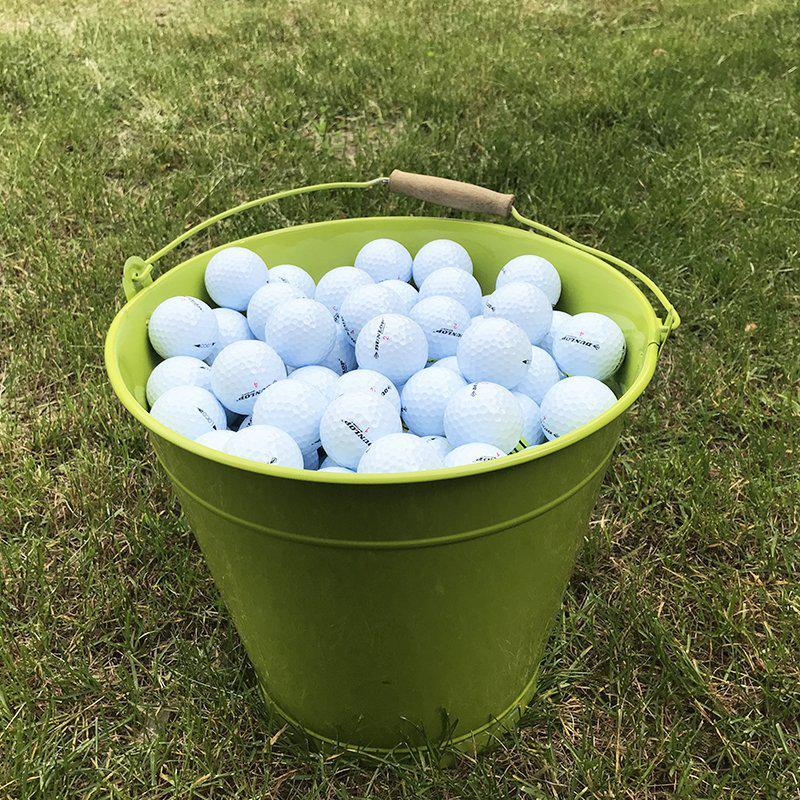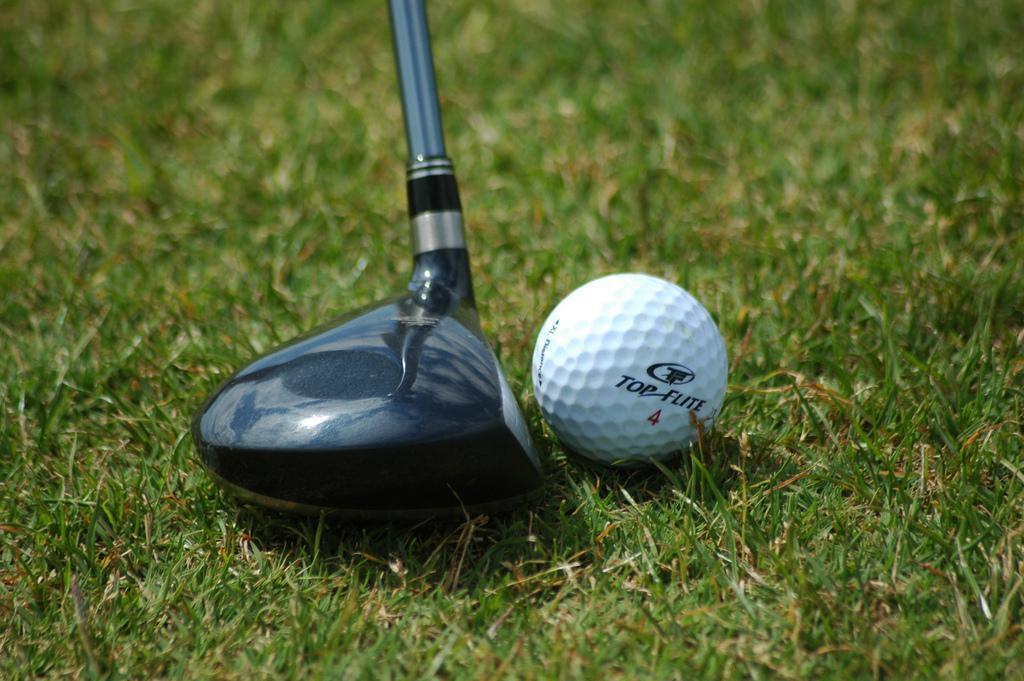The first image is the image on the left, the second image is the image on the right. For the images shown, is this caption "An image shows a club right next to a golf ball." true? Answer yes or no. Yes. The first image is the image on the left, the second image is the image on the right. Assess this claim about the two images: "One of the images contain a golf ball right next to a golf club.". Correct or not? Answer yes or no. Yes. 